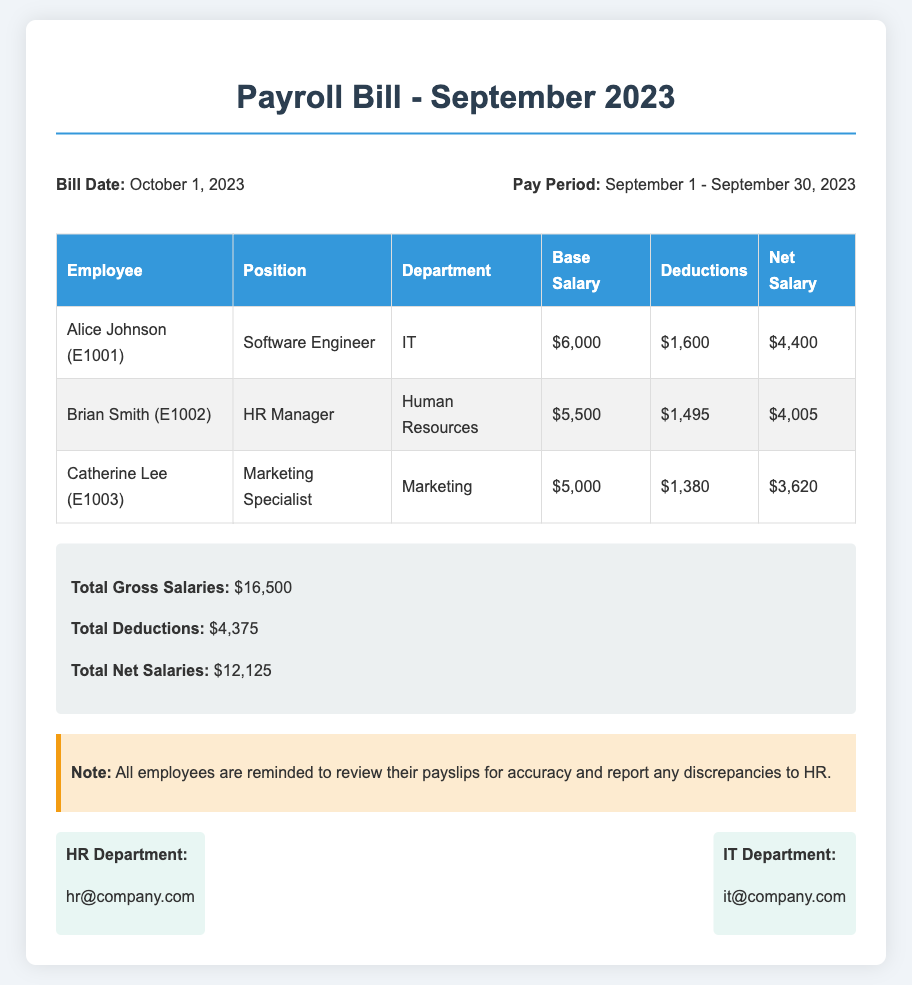What is the bill date? The bill date is stated in the header section of the document as October 1, 2023.
Answer: October 1, 2023 Who is the HR Manager? The HR Manager is listed in the employee table under the position column, which is Brian Smith.
Answer: Brian Smith What was Alice Johnson's base salary? The base salary for Alice Johnson is found in the employee table next to her name, which is $6,000.
Answer: $6,000 What is the total net salary? The total net salary is summarized at the bottom of the document, specifically noted as $12,125.
Answer: $12,125 How much were total deductions? The total deductions are outlined in the total section of the document, which amounts to $4,375.
Answer: $4,375 What department does Catherine Lee work in? Catherine Lee's department can be found in the employee table under the department column, which specifies Marketing.
Answer: Marketing What is the position of Alice Johnson? Alice Johnson's position is indicated in the employee table, which states she is a Software Engineer.
Answer: Software Engineer What should employees do if they find discrepancies? The note section of the document specifically advises employees to report discrepancies to HR.
Answer: Report to HR Which department handles employee salaries? The HR department is mentioned in the document related to managing salaries and issues, as indicated in the contact section.
Answer: HR Department 